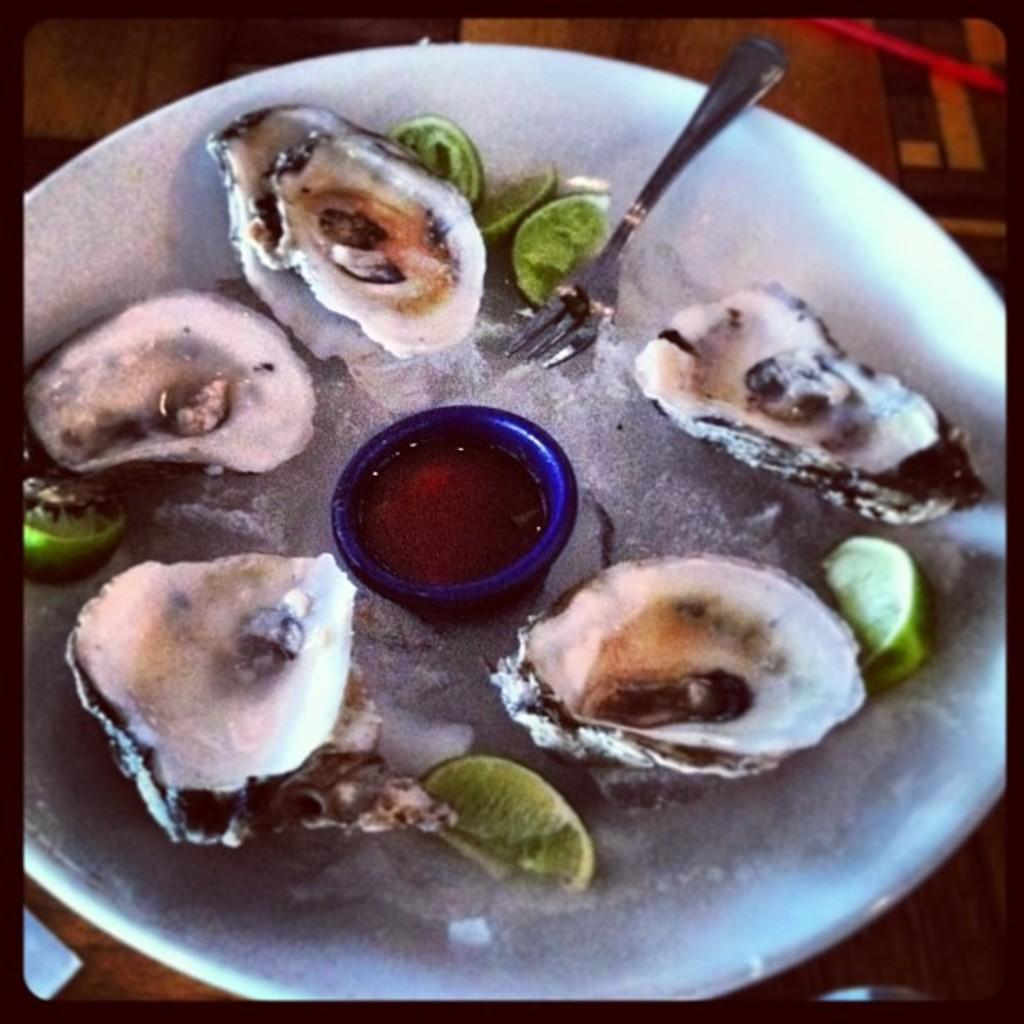What is on the plate in the image? The plate contains shells and lemon slices. What utensil is present in the image? There is a fork in the image. What type of container is visible in the image? There is a cup in the image. Where are the plate, fork, and cup placed? They are placed on a surface. What word is spelled out using the shells on the plate? There is no word spelled out using the shells on the plate; the shells are simply arranged on the plate. What arithmetic problem can be solved using the lemon slices on the plate? There is no arithmetic problem that can be solved using the lemon slices on the plate; they are simply arranged on the plate as well. 